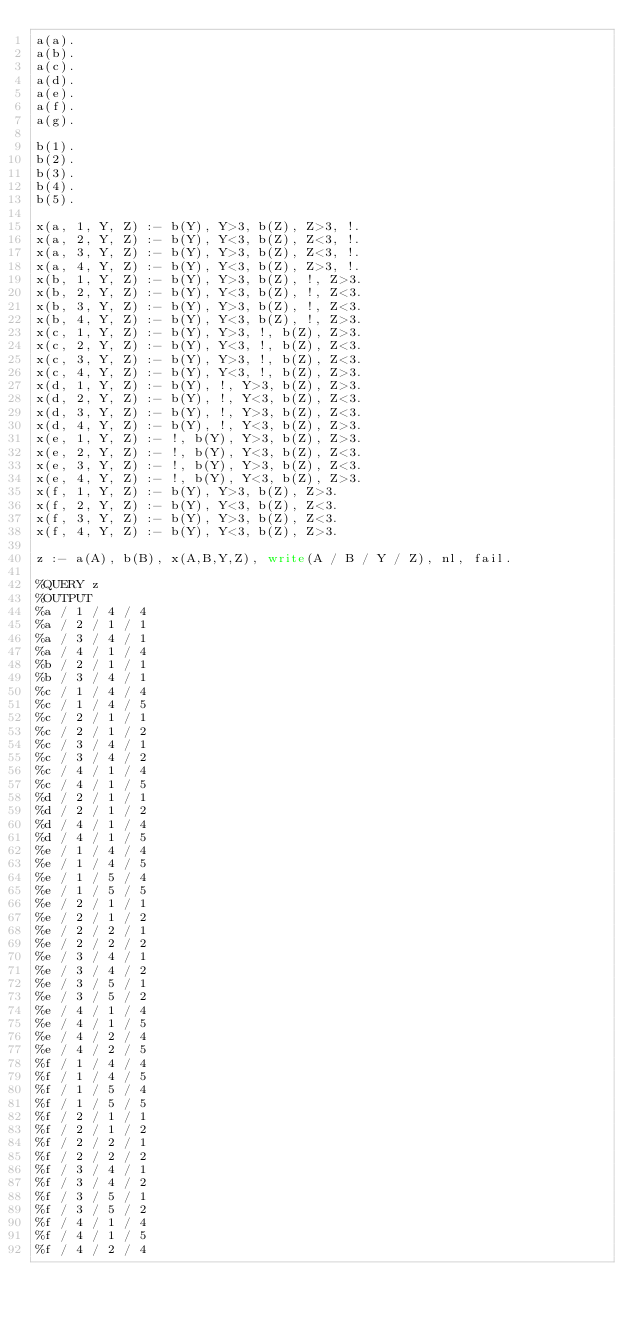<code> <loc_0><loc_0><loc_500><loc_500><_Perl_>a(a).
a(b).
a(c).
a(d).
a(e).
a(f).
a(g).

b(1).
b(2).
b(3).
b(4).
b(5).

x(a, 1, Y, Z) :- b(Y), Y>3, b(Z), Z>3, !.
x(a, 2, Y, Z) :- b(Y), Y<3, b(Z), Z<3, !.
x(a, 3, Y, Z) :- b(Y), Y>3, b(Z), Z<3, !.
x(a, 4, Y, Z) :- b(Y), Y<3, b(Z), Z>3, !.
x(b, 1, Y, Z) :- b(Y), Y>3, b(Z), !, Z>3.
x(b, 2, Y, Z) :- b(Y), Y<3, b(Z), !, Z<3.
x(b, 3, Y, Z) :- b(Y), Y>3, b(Z), !, Z<3.
x(b, 4, Y, Z) :- b(Y), Y<3, b(Z), !, Z>3.
x(c, 1, Y, Z) :- b(Y), Y>3, !, b(Z), Z>3.
x(c, 2, Y, Z) :- b(Y), Y<3, !, b(Z), Z<3.
x(c, 3, Y, Z) :- b(Y), Y>3, !, b(Z), Z<3.
x(c, 4, Y, Z) :- b(Y), Y<3, !, b(Z), Z>3.
x(d, 1, Y, Z) :- b(Y), !, Y>3, b(Z), Z>3.
x(d, 2, Y, Z) :- b(Y), !, Y<3, b(Z), Z<3.
x(d, 3, Y, Z) :- b(Y), !, Y>3, b(Z), Z<3.
x(d, 4, Y, Z) :- b(Y), !, Y<3, b(Z), Z>3.
x(e, 1, Y, Z) :- !, b(Y), Y>3, b(Z), Z>3.
x(e, 2, Y, Z) :- !, b(Y), Y<3, b(Z), Z<3.
x(e, 3, Y, Z) :- !, b(Y), Y>3, b(Z), Z<3.
x(e, 4, Y, Z) :- !, b(Y), Y<3, b(Z), Z>3.
x(f, 1, Y, Z) :- b(Y), Y>3, b(Z), Z>3.
x(f, 2, Y, Z) :- b(Y), Y<3, b(Z), Z<3.
x(f, 3, Y, Z) :- b(Y), Y>3, b(Z), Z<3.
x(f, 4, Y, Z) :- b(Y), Y<3, b(Z), Z>3.

z :- a(A), b(B), x(A,B,Y,Z), write(A / B / Y / Z), nl, fail.

%QUERY z
%OUTPUT
%a / 1 / 4 / 4
%a / 2 / 1 / 1
%a / 3 / 4 / 1
%a / 4 / 1 / 4
%b / 2 / 1 / 1
%b / 3 / 4 / 1
%c / 1 / 4 / 4
%c / 1 / 4 / 5
%c / 2 / 1 / 1
%c / 2 / 1 / 2
%c / 3 / 4 / 1
%c / 3 / 4 / 2
%c / 4 / 1 / 4
%c / 4 / 1 / 5
%d / 2 / 1 / 1
%d / 2 / 1 / 2
%d / 4 / 1 / 4
%d / 4 / 1 / 5
%e / 1 / 4 / 4
%e / 1 / 4 / 5
%e / 1 / 5 / 4
%e / 1 / 5 / 5
%e / 2 / 1 / 1
%e / 2 / 1 / 2
%e / 2 / 2 / 1
%e / 2 / 2 / 2
%e / 3 / 4 / 1
%e / 3 / 4 / 2
%e / 3 / 5 / 1
%e / 3 / 5 / 2
%e / 4 / 1 / 4
%e / 4 / 1 / 5
%e / 4 / 2 / 4
%e / 4 / 2 / 5
%f / 1 / 4 / 4
%f / 1 / 4 / 5
%f / 1 / 5 / 4
%f / 1 / 5 / 5
%f / 2 / 1 / 1
%f / 2 / 1 / 2
%f / 2 / 2 / 1
%f / 2 / 2 / 2
%f / 3 / 4 / 1
%f / 3 / 4 / 2
%f / 3 / 5 / 1
%f / 3 / 5 / 2
%f / 4 / 1 / 4
%f / 4 / 1 / 5
%f / 4 / 2 / 4</code> 